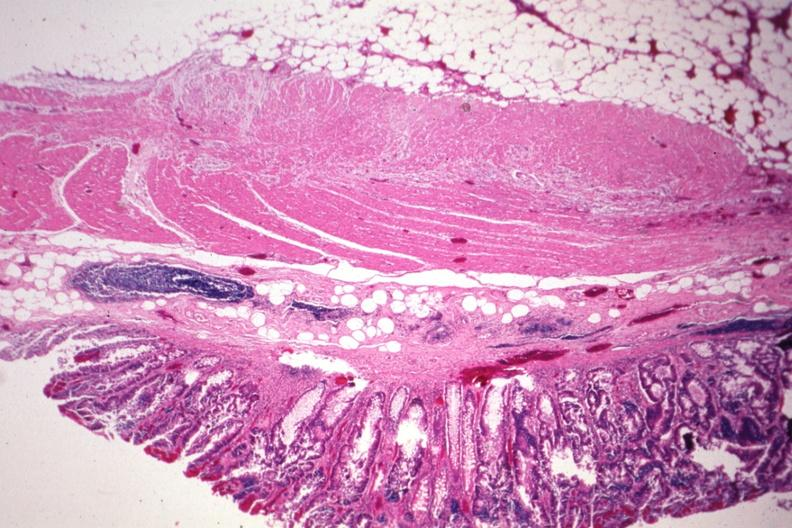s endocrine present?
Answer the question using a single word or phrase. No 